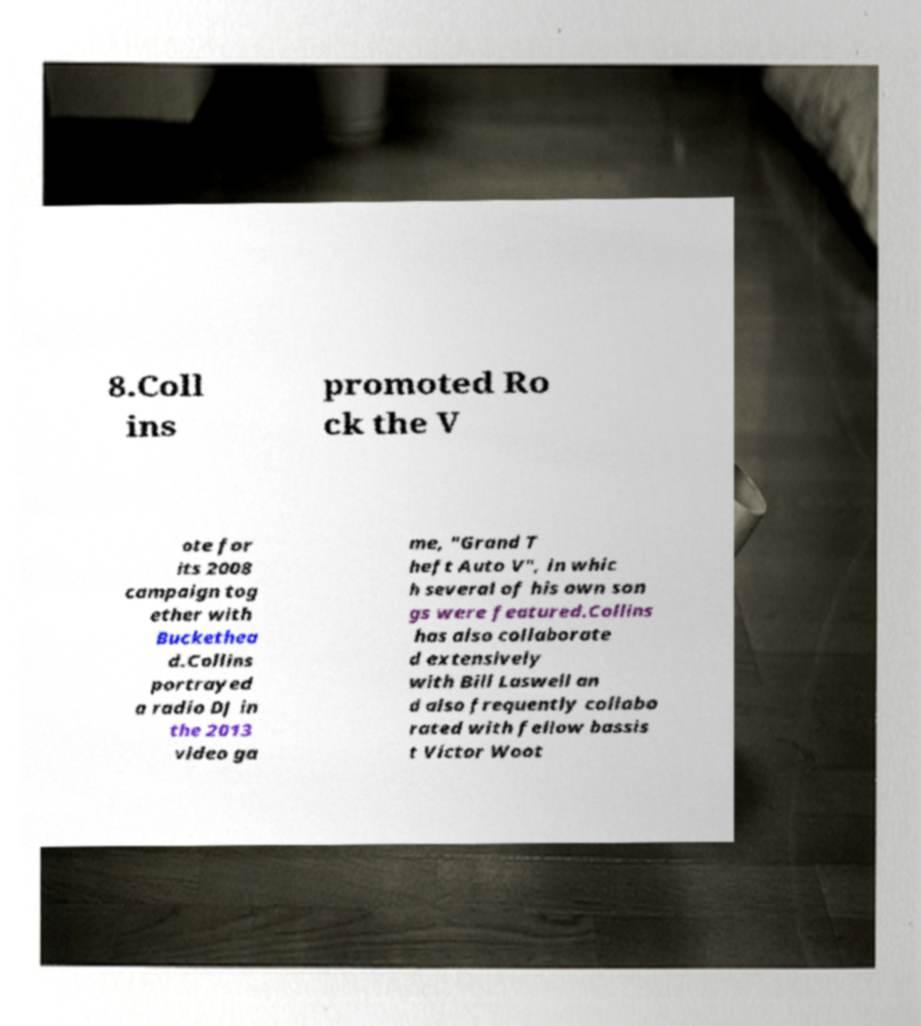Can you read and provide the text displayed in the image?This photo seems to have some interesting text. Can you extract and type it out for me? 8.Coll ins promoted Ro ck the V ote for its 2008 campaign tog ether with Buckethea d.Collins portrayed a radio DJ in the 2013 video ga me, "Grand T heft Auto V", in whic h several of his own son gs were featured.Collins has also collaborate d extensively with Bill Laswell an d also frequently collabo rated with fellow bassis t Victor Woot 